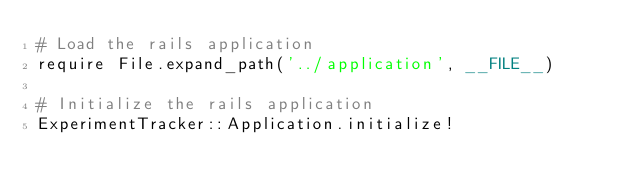Convert code to text. <code><loc_0><loc_0><loc_500><loc_500><_Ruby_># Load the rails application
require File.expand_path('../application', __FILE__)

# Initialize the rails application
ExperimentTracker::Application.initialize!
</code> 